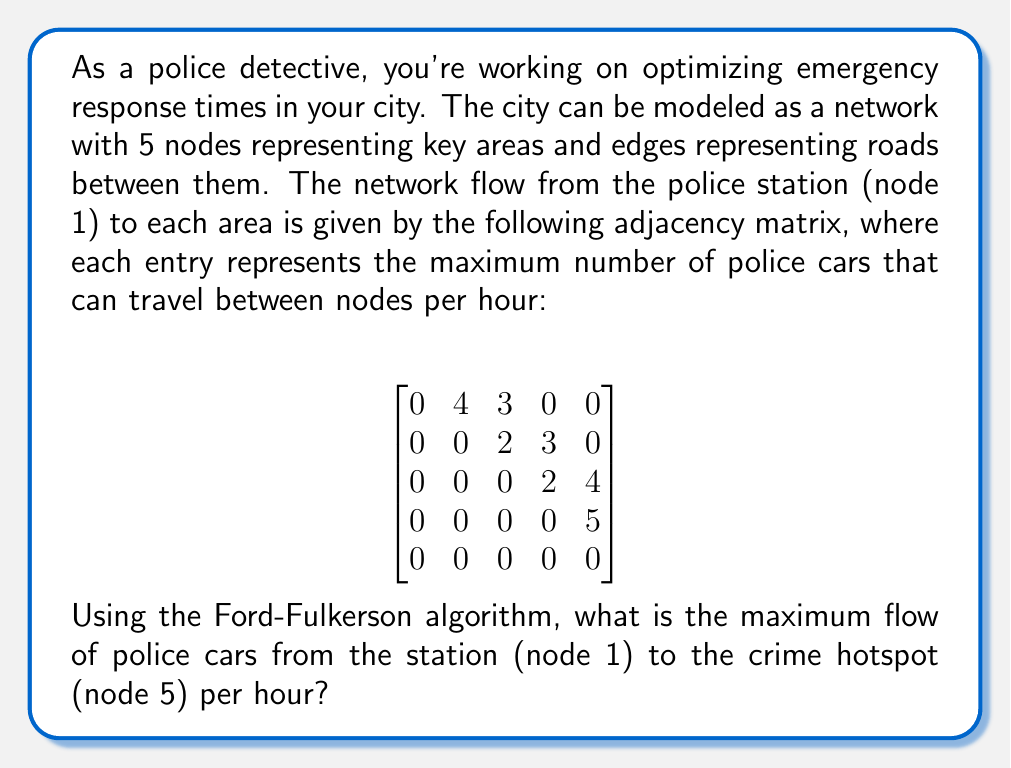Solve this math problem. To solve this problem using the Ford-Fulkerson algorithm, we'll follow these steps:

1) First, let's visualize the network:

[asy]
import graph;

size(200);

void drawNode(pair p, string s) {
  fill(circle(p, 0.3), white);
  draw(circle(p, 0.3));
  label(s, p);
}

pair[] pos = {(0,0), (2,2), (2,-2), (4,2), (4,-2)};
string[] labels = {"1", "2", "3", "4", "5"};

for(int i = 0; i < 5; ++i) {
  drawNode(pos[i], labels[i]);
}

draw(pos[0]--pos[1], arrow=Arrow(TeXHead), L="4");
draw(pos[0]--pos[2], arrow=Arrow(TeXHead), L="3");
draw(pos[1]--pos[3], arrow=Arrow(TeXHead), L="3");
draw(pos[1]--pos[2], arrow=Arrow(TeXHead), L="2");
draw(pos[2]--pos[3], arrow=Arrow(TeXHead), L="2");
draw(pos[2]--pos[4], arrow=Arrow(TeXHead), L="4");
draw(pos[3]--pos[4], arrow=Arrow(TeXHead), L="5");
[/asy]

2) We'll now apply the Ford-Fulkerson algorithm:

   a) Find a path from source (1) to sink (5) with available capacity. Augment the flow along this path.
   b) Repeat until no more paths are available.

3) Let's trace the paths:

   Path 1: 1 -> 2 -> 4 -> 5
   Flow: min(4, 3, 5) = 3
   Residual capacities: (1,2): 1, (2,4): 0, (4,5): 2

   Path 2: 1 -> 3 -> 5
   Flow: min(3, 4) = 3
   Residual capacities: (1,3): 0, (3,5): 1

   Path 3: 1 -> 2 -> 3 -> 5
   Flow: min(1, 2, 1) = 1
   Residual capacities: (1,2): 0, (2,3): 1, (3,5): 0

4) No more paths are available from 1 to 5.

5) The maximum flow is the sum of flows along all paths:
   3 + 3 + 1 = 7
Answer: The maximum flow of police cars from the station (node 1) to the crime hotspot (node 5) per hour is 7. 